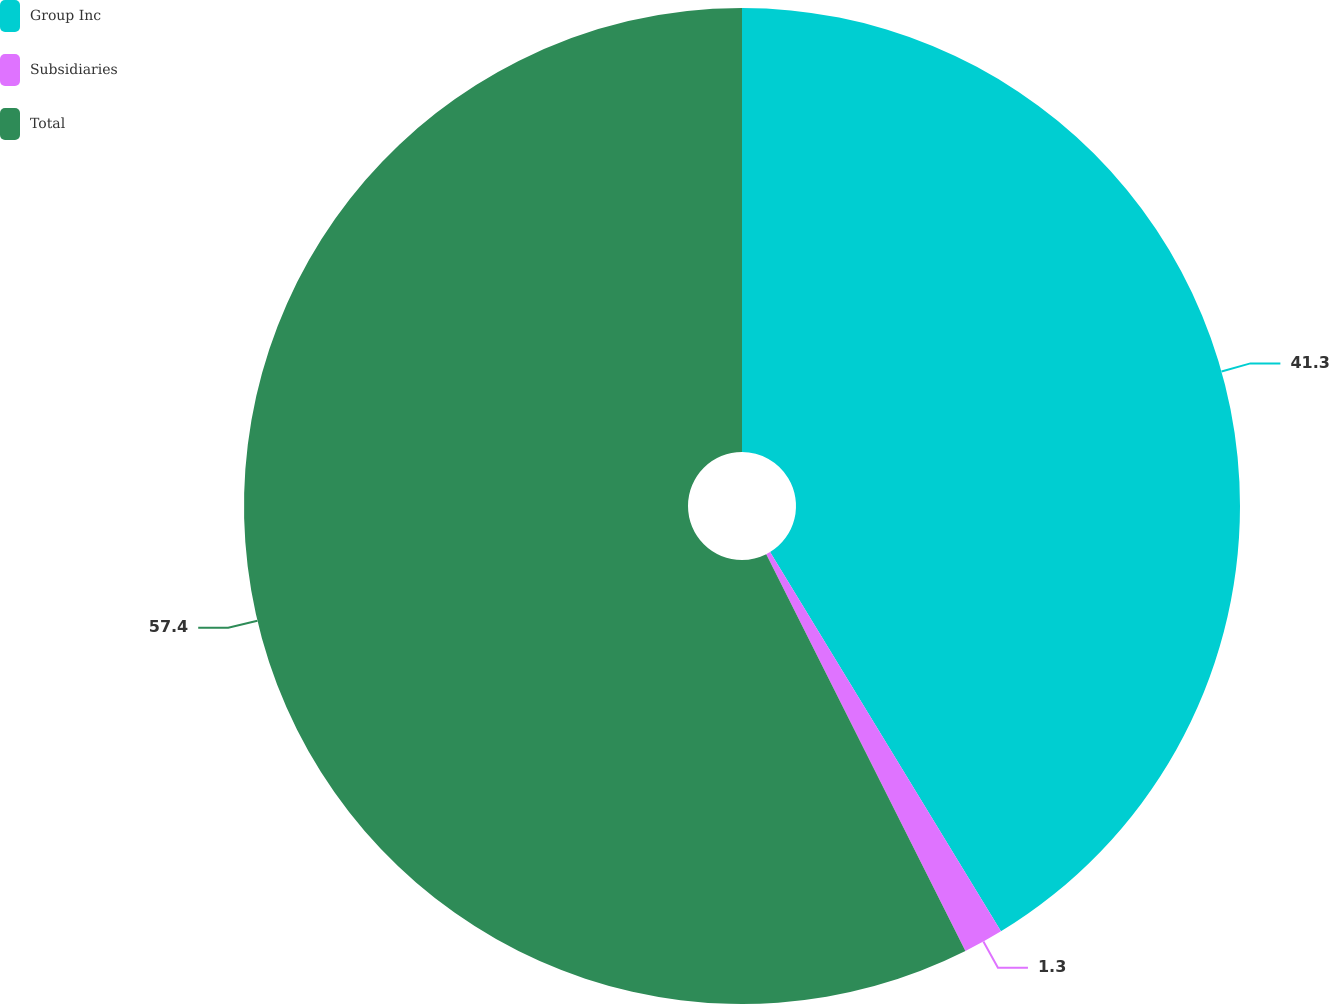Convert chart. <chart><loc_0><loc_0><loc_500><loc_500><pie_chart><fcel>Group Inc<fcel>Subsidiaries<fcel>Total<nl><fcel>41.3%<fcel>1.3%<fcel>57.41%<nl></chart> 